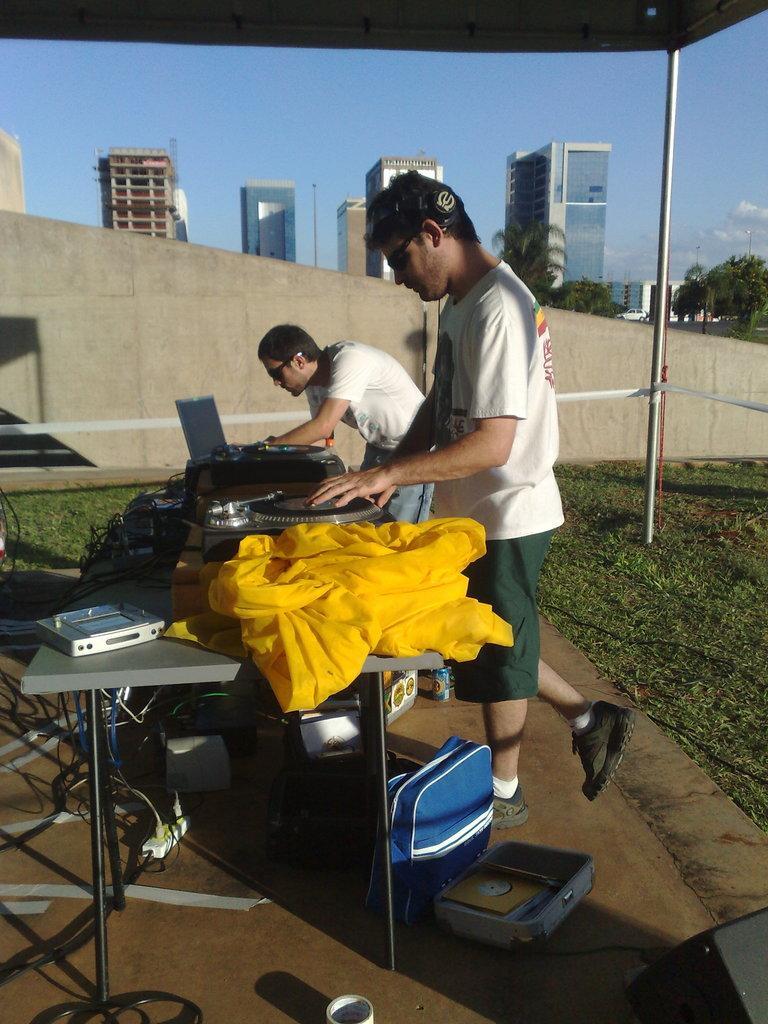Can you describe this image briefly? Far there are buildings and trees. Under the tent this two persons are standing. In-front of this person's there is a table, on a table there is a DJ, cloth and device. Under the table there is a bag. 